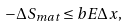<formula> <loc_0><loc_0><loc_500><loc_500>- \Delta S _ { m a t } \leq b E \Delta x ,</formula> 